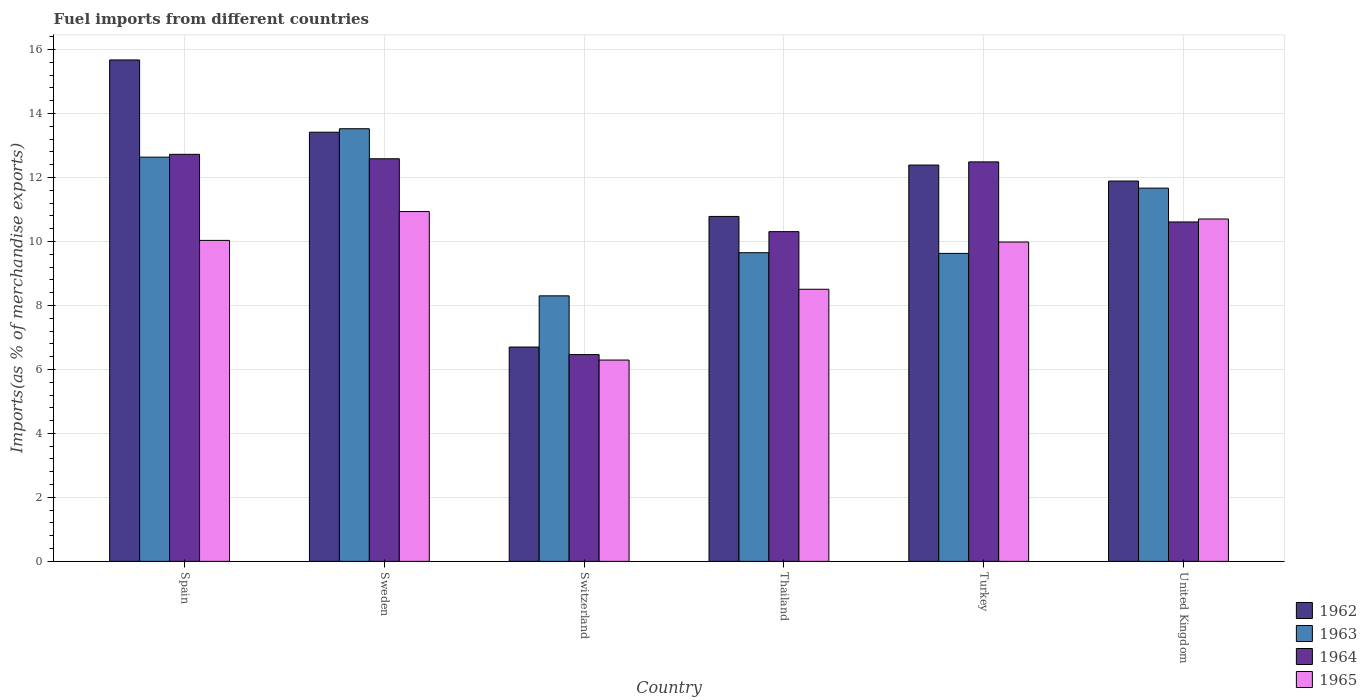How many different coloured bars are there?
Make the answer very short. 4. Are the number of bars on each tick of the X-axis equal?
Your answer should be very brief. Yes. How many bars are there on the 6th tick from the left?
Keep it short and to the point. 4. How many bars are there on the 5th tick from the right?
Keep it short and to the point. 4. What is the label of the 3rd group of bars from the left?
Keep it short and to the point. Switzerland. In how many cases, is the number of bars for a given country not equal to the number of legend labels?
Keep it short and to the point. 0. What is the percentage of imports to different countries in 1962 in Switzerland?
Your answer should be compact. 6.7. Across all countries, what is the maximum percentage of imports to different countries in 1965?
Offer a terse response. 10.93. Across all countries, what is the minimum percentage of imports to different countries in 1962?
Provide a short and direct response. 6.7. In which country was the percentage of imports to different countries in 1964 maximum?
Provide a short and direct response. Spain. In which country was the percentage of imports to different countries in 1962 minimum?
Provide a succinct answer. Switzerland. What is the total percentage of imports to different countries in 1965 in the graph?
Give a very brief answer. 56.45. What is the difference between the percentage of imports to different countries in 1962 in Sweden and that in United Kingdom?
Provide a succinct answer. 1.53. What is the difference between the percentage of imports to different countries in 1962 in Thailand and the percentage of imports to different countries in 1963 in Switzerland?
Your answer should be compact. 2.48. What is the average percentage of imports to different countries in 1962 per country?
Your answer should be very brief. 11.81. What is the difference between the percentage of imports to different countries of/in 1963 and percentage of imports to different countries of/in 1964 in United Kingdom?
Provide a short and direct response. 1.06. What is the ratio of the percentage of imports to different countries in 1963 in Spain to that in United Kingdom?
Ensure brevity in your answer.  1.08. Is the difference between the percentage of imports to different countries in 1963 in Spain and Turkey greater than the difference between the percentage of imports to different countries in 1964 in Spain and Turkey?
Ensure brevity in your answer.  Yes. What is the difference between the highest and the second highest percentage of imports to different countries in 1962?
Make the answer very short. -1.03. What is the difference between the highest and the lowest percentage of imports to different countries in 1963?
Make the answer very short. 5.22. What does the 1st bar from the left in United Kingdom represents?
Provide a short and direct response. 1962. What does the 1st bar from the right in Sweden represents?
Your answer should be compact. 1965. What is the difference between two consecutive major ticks on the Y-axis?
Your answer should be compact. 2. Does the graph contain any zero values?
Your response must be concise. No. Does the graph contain grids?
Your answer should be very brief. Yes. Where does the legend appear in the graph?
Your answer should be compact. Bottom right. How are the legend labels stacked?
Ensure brevity in your answer.  Vertical. What is the title of the graph?
Offer a terse response. Fuel imports from different countries. What is the label or title of the X-axis?
Your response must be concise. Country. What is the label or title of the Y-axis?
Give a very brief answer. Imports(as % of merchandise exports). What is the Imports(as % of merchandise exports) in 1962 in Spain?
Your response must be concise. 15.67. What is the Imports(as % of merchandise exports) in 1963 in Spain?
Make the answer very short. 12.64. What is the Imports(as % of merchandise exports) in 1964 in Spain?
Make the answer very short. 12.72. What is the Imports(as % of merchandise exports) in 1965 in Spain?
Provide a succinct answer. 10.03. What is the Imports(as % of merchandise exports) of 1962 in Sweden?
Provide a succinct answer. 13.42. What is the Imports(as % of merchandise exports) in 1963 in Sweden?
Ensure brevity in your answer.  13.52. What is the Imports(as % of merchandise exports) in 1964 in Sweden?
Offer a terse response. 12.58. What is the Imports(as % of merchandise exports) in 1965 in Sweden?
Provide a short and direct response. 10.93. What is the Imports(as % of merchandise exports) of 1962 in Switzerland?
Keep it short and to the point. 6.7. What is the Imports(as % of merchandise exports) of 1963 in Switzerland?
Make the answer very short. 8.3. What is the Imports(as % of merchandise exports) of 1964 in Switzerland?
Your answer should be compact. 6.46. What is the Imports(as % of merchandise exports) in 1965 in Switzerland?
Keep it short and to the point. 6.29. What is the Imports(as % of merchandise exports) of 1962 in Thailand?
Ensure brevity in your answer.  10.78. What is the Imports(as % of merchandise exports) in 1963 in Thailand?
Your answer should be compact. 9.65. What is the Imports(as % of merchandise exports) in 1964 in Thailand?
Keep it short and to the point. 10.31. What is the Imports(as % of merchandise exports) of 1965 in Thailand?
Provide a succinct answer. 8.51. What is the Imports(as % of merchandise exports) in 1962 in Turkey?
Keep it short and to the point. 12.39. What is the Imports(as % of merchandise exports) in 1963 in Turkey?
Offer a very short reply. 9.63. What is the Imports(as % of merchandise exports) in 1964 in Turkey?
Make the answer very short. 12.49. What is the Imports(as % of merchandise exports) in 1965 in Turkey?
Keep it short and to the point. 9.98. What is the Imports(as % of merchandise exports) of 1962 in United Kingdom?
Ensure brevity in your answer.  11.89. What is the Imports(as % of merchandise exports) in 1963 in United Kingdom?
Your answer should be very brief. 11.67. What is the Imports(as % of merchandise exports) in 1964 in United Kingdom?
Offer a terse response. 10.61. What is the Imports(as % of merchandise exports) in 1965 in United Kingdom?
Make the answer very short. 10.7. Across all countries, what is the maximum Imports(as % of merchandise exports) of 1962?
Give a very brief answer. 15.67. Across all countries, what is the maximum Imports(as % of merchandise exports) of 1963?
Give a very brief answer. 13.52. Across all countries, what is the maximum Imports(as % of merchandise exports) in 1964?
Provide a succinct answer. 12.72. Across all countries, what is the maximum Imports(as % of merchandise exports) of 1965?
Ensure brevity in your answer.  10.93. Across all countries, what is the minimum Imports(as % of merchandise exports) of 1962?
Your answer should be very brief. 6.7. Across all countries, what is the minimum Imports(as % of merchandise exports) of 1963?
Your response must be concise. 8.3. Across all countries, what is the minimum Imports(as % of merchandise exports) in 1964?
Provide a succinct answer. 6.46. Across all countries, what is the minimum Imports(as % of merchandise exports) of 1965?
Your answer should be compact. 6.29. What is the total Imports(as % of merchandise exports) in 1962 in the graph?
Offer a terse response. 70.85. What is the total Imports(as % of merchandise exports) in 1963 in the graph?
Your answer should be very brief. 65.4. What is the total Imports(as % of merchandise exports) in 1964 in the graph?
Your answer should be compact. 65.18. What is the total Imports(as % of merchandise exports) in 1965 in the graph?
Your answer should be very brief. 56.45. What is the difference between the Imports(as % of merchandise exports) of 1962 in Spain and that in Sweden?
Ensure brevity in your answer.  2.26. What is the difference between the Imports(as % of merchandise exports) of 1963 in Spain and that in Sweden?
Your response must be concise. -0.89. What is the difference between the Imports(as % of merchandise exports) of 1964 in Spain and that in Sweden?
Provide a succinct answer. 0.14. What is the difference between the Imports(as % of merchandise exports) in 1965 in Spain and that in Sweden?
Offer a very short reply. -0.9. What is the difference between the Imports(as % of merchandise exports) of 1962 in Spain and that in Switzerland?
Ensure brevity in your answer.  8.97. What is the difference between the Imports(as % of merchandise exports) of 1963 in Spain and that in Switzerland?
Make the answer very short. 4.34. What is the difference between the Imports(as % of merchandise exports) of 1964 in Spain and that in Switzerland?
Your answer should be compact. 6.26. What is the difference between the Imports(as % of merchandise exports) of 1965 in Spain and that in Switzerland?
Your response must be concise. 3.74. What is the difference between the Imports(as % of merchandise exports) in 1962 in Spain and that in Thailand?
Give a very brief answer. 4.89. What is the difference between the Imports(as % of merchandise exports) in 1963 in Spain and that in Thailand?
Your response must be concise. 2.99. What is the difference between the Imports(as % of merchandise exports) of 1964 in Spain and that in Thailand?
Offer a very short reply. 2.42. What is the difference between the Imports(as % of merchandise exports) of 1965 in Spain and that in Thailand?
Keep it short and to the point. 1.53. What is the difference between the Imports(as % of merchandise exports) of 1962 in Spain and that in Turkey?
Ensure brevity in your answer.  3.29. What is the difference between the Imports(as % of merchandise exports) of 1963 in Spain and that in Turkey?
Ensure brevity in your answer.  3.01. What is the difference between the Imports(as % of merchandise exports) of 1964 in Spain and that in Turkey?
Your answer should be compact. 0.24. What is the difference between the Imports(as % of merchandise exports) of 1965 in Spain and that in Turkey?
Your response must be concise. 0.05. What is the difference between the Imports(as % of merchandise exports) in 1962 in Spain and that in United Kingdom?
Give a very brief answer. 3.79. What is the difference between the Imports(as % of merchandise exports) of 1963 in Spain and that in United Kingdom?
Provide a succinct answer. 0.97. What is the difference between the Imports(as % of merchandise exports) in 1964 in Spain and that in United Kingdom?
Your answer should be very brief. 2.11. What is the difference between the Imports(as % of merchandise exports) of 1965 in Spain and that in United Kingdom?
Ensure brevity in your answer.  -0.67. What is the difference between the Imports(as % of merchandise exports) in 1962 in Sweden and that in Switzerland?
Make the answer very short. 6.72. What is the difference between the Imports(as % of merchandise exports) of 1963 in Sweden and that in Switzerland?
Your answer should be very brief. 5.22. What is the difference between the Imports(as % of merchandise exports) in 1964 in Sweden and that in Switzerland?
Provide a short and direct response. 6.12. What is the difference between the Imports(as % of merchandise exports) in 1965 in Sweden and that in Switzerland?
Your answer should be very brief. 4.64. What is the difference between the Imports(as % of merchandise exports) in 1962 in Sweden and that in Thailand?
Ensure brevity in your answer.  2.63. What is the difference between the Imports(as % of merchandise exports) in 1963 in Sweden and that in Thailand?
Make the answer very short. 3.88. What is the difference between the Imports(as % of merchandise exports) of 1964 in Sweden and that in Thailand?
Provide a succinct answer. 2.28. What is the difference between the Imports(as % of merchandise exports) in 1965 in Sweden and that in Thailand?
Give a very brief answer. 2.43. What is the difference between the Imports(as % of merchandise exports) in 1962 in Sweden and that in Turkey?
Your answer should be very brief. 1.03. What is the difference between the Imports(as % of merchandise exports) of 1963 in Sweden and that in Turkey?
Your answer should be compact. 3.9. What is the difference between the Imports(as % of merchandise exports) of 1964 in Sweden and that in Turkey?
Keep it short and to the point. 0.1. What is the difference between the Imports(as % of merchandise exports) in 1965 in Sweden and that in Turkey?
Your response must be concise. 0.95. What is the difference between the Imports(as % of merchandise exports) of 1962 in Sweden and that in United Kingdom?
Your response must be concise. 1.53. What is the difference between the Imports(as % of merchandise exports) of 1963 in Sweden and that in United Kingdom?
Your answer should be very brief. 1.86. What is the difference between the Imports(as % of merchandise exports) in 1964 in Sweden and that in United Kingdom?
Your answer should be compact. 1.97. What is the difference between the Imports(as % of merchandise exports) in 1965 in Sweden and that in United Kingdom?
Offer a terse response. 0.23. What is the difference between the Imports(as % of merchandise exports) of 1962 in Switzerland and that in Thailand?
Provide a short and direct response. -4.08. What is the difference between the Imports(as % of merchandise exports) in 1963 in Switzerland and that in Thailand?
Make the answer very short. -1.35. What is the difference between the Imports(as % of merchandise exports) in 1964 in Switzerland and that in Thailand?
Keep it short and to the point. -3.84. What is the difference between the Imports(as % of merchandise exports) in 1965 in Switzerland and that in Thailand?
Your answer should be compact. -2.21. What is the difference between the Imports(as % of merchandise exports) in 1962 in Switzerland and that in Turkey?
Make the answer very short. -5.69. What is the difference between the Imports(as % of merchandise exports) in 1963 in Switzerland and that in Turkey?
Provide a short and direct response. -1.33. What is the difference between the Imports(as % of merchandise exports) of 1964 in Switzerland and that in Turkey?
Ensure brevity in your answer.  -6.02. What is the difference between the Imports(as % of merchandise exports) in 1965 in Switzerland and that in Turkey?
Your answer should be very brief. -3.69. What is the difference between the Imports(as % of merchandise exports) of 1962 in Switzerland and that in United Kingdom?
Offer a very short reply. -5.19. What is the difference between the Imports(as % of merchandise exports) of 1963 in Switzerland and that in United Kingdom?
Your response must be concise. -3.37. What is the difference between the Imports(as % of merchandise exports) in 1964 in Switzerland and that in United Kingdom?
Make the answer very short. -4.15. What is the difference between the Imports(as % of merchandise exports) of 1965 in Switzerland and that in United Kingdom?
Your answer should be compact. -4.41. What is the difference between the Imports(as % of merchandise exports) of 1962 in Thailand and that in Turkey?
Your answer should be very brief. -1.61. What is the difference between the Imports(as % of merchandise exports) in 1963 in Thailand and that in Turkey?
Provide a succinct answer. 0.02. What is the difference between the Imports(as % of merchandise exports) of 1964 in Thailand and that in Turkey?
Make the answer very short. -2.18. What is the difference between the Imports(as % of merchandise exports) of 1965 in Thailand and that in Turkey?
Provide a succinct answer. -1.48. What is the difference between the Imports(as % of merchandise exports) of 1962 in Thailand and that in United Kingdom?
Keep it short and to the point. -1.11. What is the difference between the Imports(as % of merchandise exports) in 1963 in Thailand and that in United Kingdom?
Provide a short and direct response. -2.02. What is the difference between the Imports(as % of merchandise exports) of 1964 in Thailand and that in United Kingdom?
Give a very brief answer. -0.3. What is the difference between the Imports(as % of merchandise exports) in 1965 in Thailand and that in United Kingdom?
Provide a succinct answer. -2.2. What is the difference between the Imports(as % of merchandise exports) of 1962 in Turkey and that in United Kingdom?
Make the answer very short. 0.5. What is the difference between the Imports(as % of merchandise exports) of 1963 in Turkey and that in United Kingdom?
Keep it short and to the point. -2.04. What is the difference between the Imports(as % of merchandise exports) of 1964 in Turkey and that in United Kingdom?
Provide a short and direct response. 1.88. What is the difference between the Imports(as % of merchandise exports) in 1965 in Turkey and that in United Kingdom?
Make the answer very short. -0.72. What is the difference between the Imports(as % of merchandise exports) of 1962 in Spain and the Imports(as % of merchandise exports) of 1963 in Sweden?
Your answer should be compact. 2.15. What is the difference between the Imports(as % of merchandise exports) in 1962 in Spain and the Imports(as % of merchandise exports) in 1964 in Sweden?
Ensure brevity in your answer.  3.09. What is the difference between the Imports(as % of merchandise exports) in 1962 in Spain and the Imports(as % of merchandise exports) in 1965 in Sweden?
Offer a very short reply. 4.74. What is the difference between the Imports(as % of merchandise exports) of 1963 in Spain and the Imports(as % of merchandise exports) of 1964 in Sweden?
Give a very brief answer. 0.05. What is the difference between the Imports(as % of merchandise exports) of 1963 in Spain and the Imports(as % of merchandise exports) of 1965 in Sweden?
Your answer should be compact. 1.7. What is the difference between the Imports(as % of merchandise exports) in 1964 in Spain and the Imports(as % of merchandise exports) in 1965 in Sweden?
Your response must be concise. 1.79. What is the difference between the Imports(as % of merchandise exports) in 1962 in Spain and the Imports(as % of merchandise exports) in 1963 in Switzerland?
Make the answer very short. 7.37. What is the difference between the Imports(as % of merchandise exports) in 1962 in Spain and the Imports(as % of merchandise exports) in 1964 in Switzerland?
Offer a very short reply. 9.21. What is the difference between the Imports(as % of merchandise exports) of 1962 in Spain and the Imports(as % of merchandise exports) of 1965 in Switzerland?
Make the answer very short. 9.38. What is the difference between the Imports(as % of merchandise exports) of 1963 in Spain and the Imports(as % of merchandise exports) of 1964 in Switzerland?
Provide a succinct answer. 6.17. What is the difference between the Imports(as % of merchandise exports) of 1963 in Spain and the Imports(as % of merchandise exports) of 1965 in Switzerland?
Your answer should be compact. 6.34. What is the difference between the Imports(as % of merchandise exports) in 1964 in Spain and the Imports(as % of merchandise exports) in 1965 in Switzerland?
Give a very brief answer. 6.43. What is the difference between the Imports(as % of merchandise exports) in 1962 in Spain and the Imports(as % of merchandise exports) in 1963 in Thailand?
Provide a succinct answer. 6.03. What is the difference between the Imports(as % of merchandise exports) in 1962 in Spain and the Imports(as % of merchandise exports) in 1964 in Thailand?
Provide a succinct answer. 5.37. What is the difference between the Imports(as % of merchandise exports) of 1962 in Spain and the Imports(as % of merchandise exports) of 1965 in Thailand?
Offer a very short reply. 7.17. What is the difference between the Imports(as % of merchandise exports) of 1963 in Spain and the Imports(as % of merchandise exports) of 1964 in Thailand?
Offer a terse response. 2.33. What is the difference between the Imports(as % of merchandise exports) of 1963 in Spain and the Imports(as % of merchandise exports) of 1965 in Thailand?
Your response must be concise. 4.13. What is the difference between the Imports(as % of merchandise exports) of 1964 in Spain and the Imports(as % of merchandise exports) of 1965 in Thailand?
Offer a terse response. 4.22. What is the difference between the Imports(as % of merchandise exports) of 1962 in Spain and the Imports(as % of merchandise exports) of 1963 in Turkey?
Make the answer very short. 6.05. What is the difference between the Imports(as % of merchandise exports) of 1962 in Spain and the Imports(as % of merchandise exports) of 1964 in Turkey?
Your response must be concise. 3.19. What is the difference between the Imports(as % of merchandise exports) of 1962 in Spain and the Imports(as % of merchandise exports) of 1965 in Turkey?
Give a very brief answer. 5.69. What is the difference between the Imports(as % of merchandise exports) of 1963 in Spain and the Imports(as % of merchandise exports) of 1964 in Turkey?
Keep it short and to the point. 0.15. What is the difference between the Imports(as % of merchandise exports) of 1963 in Spain and the Imports(as % of merchandise exports) of 1965 in Turkey?
Your answer should be compact. 2.65. What is the difference between the Imports(as % of merchandise exports) of 1964 in Spain and the Imports(as % of merchandise exports) of 1965 in Turkey?
Keep it short and to the point. 2.74. What is the difference between the Imports(as % of merchandise exports) in 1962 in Spain and the Imports(as % of merchandise exports) in 1963 in United Kingdom?
Provide a short and direct response. 4.01. What is the difference between the Imports(as % of merchandise exports) of 1962 in Spain and the Imports(as % of merchandise exports) of 1964 in United Kingdom?
Give a very brief answer. 5.06. What is the difference between the Imports(as % of merchandise exports) of 1962 in Spain and the Imports(as % of merchandise exports) of 1965 in United Kingdom?
Your answer should be compact. 4.97. What is the difference between the Imports(as % of merchandise exports) of 1963 in Spain and the Imports(as % of merchandise exports) of 1964 in United Kingdom?
Offer a very short reply. 2.03. What is the difference between the Imports(as % of merchandise exports) in 1963 in Spain and the Imports(as % of merchandise exports) in 1965 in United Kingdom?
Provide a succinct answer. 1.93. What is the difference between the Imports(as % of merchandise exports) in 1964 in Spain and the Imports(as % of merchandise exports) in 1965 in United Kingdom?
Provide a succinct answer. 2.02. What is the difference between the Imports(as % of merchandise exports) in 1962 in Sweden and the Imports(as % of merchandise exports) in 1963 in Switzerland?
Provide a succinct answer. 5.12. What is the difference between the Imports(as % of merchandise exports) in 1962 in Sweden and the Imports(as % of merchandise exports) in 1964 in Switzerland?
Offer a very short reply. 6.95. What is the difference between the Imports(as % of merchandise exports) of 1962 in Sweden and the Imports(as % of merchandise exports) of 1965 in Switzerland?
Give a very brief answer. 7.12. What is the difference between the Imports(as % of merchandise exports) of 1963 in Sweden and the Imports(as % of merchandise exports) of 1964 in Switzerland?
Your response must be concise. 7.06. What is the difference between the Imports(as % of merchandise exports) in 1963 in Sweden and the Imports(as % of merchandise exports) in 1965 in Switzerland?
Give a very brief answer. 7.23. What is the difference between the Imports(as % of merchandise exports) of 1964 in Sweden and the Imports(as % of merchandise exports) of 1965 in Switzerland?
Ensure brevity in your answer.  6.29. What is the difference between the Imports(as % of merchandise exports) in 1962 in Sweden and the Imports(as % of merchandise exports) in 1963 in Thailand?
Your response must be concise. 3.77. What is the difference between the Imports(as % of merchandise exports) in 1962 in Sweden and the Imports(as % of merchandise exports) in 1964 in Thailand?
Your response must be concise. 3.11. What is the difference between the Imports(as % of merchandise exports) of 1962 in Sweden and the Imports(as % of merchandise exports) of 1965 in Thailand?
Your response must be concise. 4.91. What is the difference between the Imports(as % of merchandise exports) in 1963 in Sweden and the Imports(as % of merchandise exports) in 1964 in Thailand?
Provide a short and direct response. 3.22. What is the difference between the Imports(as % of merchandise exports) of 1963 in Sweden and the Imports(as % of merchandise exports) of 1965 in Thailand?
Offer a terse response. 5.02. What is the difference between the Imports(as % of merchandise exports) in 1964 in Sweden and the Imports(as % of merchandise exports) in 1965 in Thailand?
Your answer should be very brief. 4.08. What is the difference between the Imports(as % of merchandise exports) in 1962 in Sweden and the Imports(as % of merchandise exports) in 1963 in Turkey?
Your answer should be very brief. 3.79. What is the difference between the Imports(as % of merchandise exports) of 1962 in Sweden and the Imports(as % of merchandise exports) of 1964 in Turkey?
Ensure brevity in your answer.  0.93. What is the difference between the Imports(as % of merchandise exports) of 1962 in Sweden and the Imports(as % of merchandise exports) of 1965 in Turkey?
Offer a very short reply. 3.43. What is the difference between the Imports(as % of merchandise exports) in 1963 in Sweden and the Imports(as % of merchandise exports) in 1964 in Turkey?
Your response must be concise. 1.04. What is the difference between the Imports(as % of merchandise exports) of 1963 in Sweden and the Imports(as % of merchandise exports) of 1965 in Turkey?
Offer a very short reply. 3.54. What is the difference between the Imports(as % of merchandise exports) in 1964 in Sweden and the Imports(as % of merchandise exports) in 1965 in Turkey?
Ensure brevity in your answer.  2.6. What is the difference between the Imports(as % of merchandise exports) of 1962 in Sweden and the Imports(as % of merchandise exports) of 1963 in United Kingdom?
Ensure brevity in your answer.  1.75. What is the difference between the Imports(as % of merchandise exports) in 1962 in Sweden and the Imports(as % of merchandise exports) in 1964 in United Kingdom?
Provide a succinct answer. 2.81. What is the difference between the Imports(as % of merchandise exports) in 1962 in Sweden and the Imports(as % of merchandise exports) in 1965 in United Kingdom?
Provide a succinct answer. 2.71. What is the difference between the Imports(as % of merchandise exports) in 1963 in Sweden and the Imports(as % of merchandise exports) in 1964 in United Kingdom?
Offer a very short reply. 2.91. What is the difference between the Imports(as % of merchandise exports) of 1963 in Sweden and the Imports(as % of merchandise exports) of 1965 in United Kingdom?
Keep it short and to the point. 2.82. What is the difference between the Imports(as % of merchandise exports) of 1964 in Sweden and the Imports(as % of merchandise exports) of 1965 in United Kingdom?
Offer a very short reply. 1.88. What is the difference between the Imports(as % of merchandise exports) of 1962 in Switzerland and the Imports(as % of merchandise exports) of 1963 in Thailand?
Keep it short and to the point. -2.95. What is the difference between the Imports(as % of merchandise exports) in 1962 in Switzerland and the Imports(as % of merchandise exports) in 1964 in Thailand?
Offer a terse response. -3.61. What is the difference between the Imports(as % of merchandise exports) of 1962 in Switzerland and the Imports(as % of merchandise exports) of 1965 in Thailand?
Your answer should be very brief. -1.81. What is the difference between the Imports(as % of merchandise exports) of 1963 in Switzerland and the Imports(as % of merchandise exports) of 1964 in Thailand?
Keep it short and to the point. -2.01. What is the difference between the Imports(as % of merchandise exports) in 1963 in Switzerland and the Imports(as % of merchandise exports) in 1965 in Thailand?
Give a very brief answer. -0.21. What is the difference between the Imports(as % of merchandise exports) of 1964 in Switzerland and the Imports(as % of merchandise exports) of 1965 in Thailand?
Give a very brief answer. -2.04. What is the difference between the Imports(as % of merchandise exports) of 1962 in Switzerland and the Imports(as % of merchandise exports) of 1963 in Turkey?
Ensure brevity in your answer.  -2.93. What is the difference between the Imports(as % of merchandise exports) in 1962 in Switzerland and the Imports(as % of merchandise exports) in 1964 in Turkey?
Ensure brevity in your answer.  -5.79. What is the difference between the Imports(as % of merchandise exports) of 1962 in Switzerland and the Imports(as % of merchandise exports) of 1965 in Turkey?
Offer a terse response. -3.28. What is the difference between the Imports(as % of merchandise exports) in 1963 in Switzerland and the Imports(as % of merchandise exports) in 1964 in Turkey?
Provide a short and direct response. -4.19. What is the difference between the Imports(as % of merchandise exports) of 1963 in Switzerland and the Imports(as % of merchandise exports) of 1965 in Turkey?
Keep it short and to the point. -1.68. What is the difference between the Imports(as % of merchandise exports) in 1964 in Switzerland and the Imports(as % of merchandise exports) in 1965 in Turkey?
Your answer should be very brief. -3.52. What is the difference between the Imports(as % of merchandise exports) of 1962 in Switzerland and the Imports(as % of merchandise exports) of 1963 in United Kingdom?
Offer a very short reply. -4.97. What is the difference between the Imports(as % of merchandise exports) of 1962 in Switzerland and the Imports(as % of merchandise exports) of 1964 in United Kingdom?
Your answer should be very brief. -3.91. What is the difference between the Imports(as % of merchandise exports) of 1962 in Switzerland and the Imports(as % of merchandise exports) of 1965 in United Kingdom?
Your answer should be very brief. -4. What is the difference between the Imports(as % of merchandise exports) of 1963 in Switzerland and the Imports(as % of merchandise exports) of 1964 in United Kingdom?
Make the answer very short. -2.31. What is the difference between the Imports(as % of merchandise exports) of 1963 in Switzerland and the Imports(as % of merchandise exports) of 1965 in United Kingdom?
Make the answer very short. -2.4. What is the difference between the Imports(as % of merchandise exports) of 1964 in Switzerland and the Imports(as % of merchandise exports) of 1965 in United Kingdom?
Make the answer very short. -4.24. What is the difference between the Imports(as % of merchandise exports) of 1962 in Thailand and the Imports(as % of merchandise exports) of 1963 in Turkey?
Your answer should be very brief. 1.16. What is the difference between the Imports(as % of merchandise exports) of 1962 in Thailand and the Imports(as % of merchandise exports) of 1964 in Turkey?
Provide a succinct answer. -1.71. What is the difference between the Imports(as % of merchandise exports) of 1962 in Thailand and the Imports(as % of merchandise exports) of 1965 in Turkey?
Your answer should be compact. 0.8. What is the difference between the Imports(as % of merchandise exports) of 1963 in Thailand and the Imports(as % of merchandise exports) of 1964 in Turkey?
Make the answer very short. -2.84. What is the difference between the Imports(as % of merchandise exports) of 1963 in Thailand and the Imports(as % of merchandise exports) of 1965 in Turkey?
Give a very brief answer. -0.33. What is the difference between the Imports(as % of merchandise exports) of 1964 in Thailand and the Imports(as % of merchandise exports) of 1965 in Turkey?
Your response must be concise. 0.32. What is the difference between the Imports(as % of merchandise exports) in 1962 in Thailand and the Imports(as % of merchandise exports) in 1963 in United Kingdom?
Your response must be concise. -0.89. What is the difference between the Imports(as % of merchandise exports) in 1962 in Thailand and the Imports(as % of merchandise exports) in 1964 in United Kingdom?
Your answer should be compact. 0.17. What is the difference between the Imports(as % of merchandise exports) of 1962 in Thailand and the Imports(as % of merchandise exports) of 1965 in United Kingdom?
Offer a terse response. 0.08. What is the difference between the Imports(as % of merchandise exports) in 1963 in Thailand and the Imports(as % of merchandise exports) in 1964 in United Kingdom?
Your response must be concise. -0.96. What is the difference between the Imports(as % of merchandise exports) of 1963 in Thailand and the Imports(as % of merchandise exports) of 1965 in United Kingdom?
Offer a very short reply. -1.05. What is the difference between the Imports(as % of merchandise exports) in 1964 in Thailand and the Imports(as % of merchandise exports) in 1965 in United Kingdom?
Give a very brief answer. -0.4. What is the difference between the Imports(as % of merchandise exports) in 1962 in Turkey and the Imports(as % of merchandise exports) in 1963 in United Kingdom?
Your response must be concise. 0.72. What is the difference between the Imports(as % of merchandise exports) in 1962 in Turkey and the Imports(as % of merchandise exports) in 1964 in United Kingdom?
Provide a succinct answer. 1.78. What is the difference between the Imports(as % of merchandise exports) in 1962 in Turkey and the Imports(as % of merchandise exports) in 1965 in United Kingdom?
Your response must be concise. 1.69. What is the difference between the Imports(as % of merchandise exports) in 1963 in Turkey and the Imports(as % of merchandise exports) in 1964 in United Kingdom?
Keep it short and to the point. -0.98. What is the difference between the Imports(as % of merchandise exports) of 1963 in Turkey and the Imports(as % of merchandise exports) of 1965 in United Kingdom?
Your answer should be very brief. -1.08. What is the difference between the Imports(as % of merchandise exports) of 1964 in Turkey and the Imports(as % of merchandise exports) of 1965 in United Kingdom?
Ensure brevity in your answer.  1.78. What is the average Imports(as % of merchandise exports) in 1962 per country?
Provide a succinct answer. 11.81. What is the average Imports(as % of merchandise exports) in 1963 per country?
Give a very brief answer. 10.9. What is the average Imports(as % of merchandise exports) in 1964 per country?
Ensure brevity in your answer.  10.86. What is the average Imports(as % of merchandise exports) of 1965 per country?
Offer a very short reply. 9.41. What is the difference between the Imports(as % of merchandise exports) in 1962 and Imports(as % of merchandise exports) in 1963 in Spain?
Ensure brevity in your answer.  3.04. What is the difference between the Imports(as % of merchandise exports) in 1962 and Imports(as % of merchandise exports) in 1964 in Spain?
Provide a short and direct response. 2.95. What is the difference between the Imports(as % of merchandise exports) in 1962 and Imports(as % of merchandise exports) in 1965 in Spain?
Provide a short and direct response. 5.64. What is the difference between the Imports(as % of merchandise exports) of 1963 and Imports(as % of merchandise exports) of 1964 in Spain?
Keep it short and to the point. -0.09. What is the difference between the Imports(as % of merchandise exports) in 1963 and Imports(as % of merchandise exports) in 1965 in Spain?
Make the answer very short. 2.6. What is the difference between the Imports(as % of merchandise exports) of 1964 and Imports(as % of merchandise exports) of 1965 in Spain?
Give a very brief answer. 2.69. What is the difference between the Imports(as % of merchandise exports) of 1962 and Imports(as % of merchandise exports) of 1963 in Sweden?
Your answer should be very brief. -0.11. What is the difference between the Imports(as % of merchandise exports) of 1962 and Imports(as % of merchandise exports) of 1964 in Sweden?
Make the answer very short. 0.83. What is the difference between the Imports(as % of merchandise exports) in 1962 and Imports(as % of merchandise exports) in 1965 in Sweden?
Offer a terse response. 2.48. What is the difference between the Imports(as % of merchandise exports) in 1963 and Imports(as % of merchandise exports) in 1964 in Sweden?
Offer a very short reply. 0.94. What is the difference between the Imports(as % of merchandise exports) of 1963 and Imports(as % of merchandise exports) of 1965 in Sweden?
Keep it short and to the point. 2.59. What is the difference between the Imports(as % of merchandise exports) of 1964 and Imports(as % of merchandise exports) of 1965 in Sweden?
Keep it short and to the point. 1.65. What is the difference between the Imports(as % of merchandise exports) of 1962 and Imports(as % of merchandise exports) of 1963 in Switzerland?
Ensure brevity in your answer.  -1.6. What is the difference between the Imports(as % of merchandise exports) of 1962 and Imports(as % of merchandise exports) of 1964 in Switzerland?
Provide a succinct answer. 0.24. What is the difference between the Imports(as % of merchandise exports) in 1962 and Imports(as % of merchandise exports) in 1965 in Switzerland?
Provide a short and direct response. 0.41. What is the difference between the Imports(as % of merchandise exports) in 1963 and Imports(as % of merchandise exports) in 1964 in Switzerland?
Keep it short and to the point. 1.84. What is the difference between the Imports(as % of merchandise exports) of 1963 and Imports(as % of merchandise exports) of 1965 in Switzerland?
Provide a succinct answer. 2.01. What is the difference between the Imports(as % of merchandise exports) of 1964 and Imports(as % of merchandise exports) of 1965 in Switzerland?
Give a very brief answer. 0.17. What is the difference between the Imports(as % of merchandise exports) of 1962 and Imports(as % of merchandise exports) of 1963 in Thailand?
Make the answer very short. 1.13. What is the difference between the Imports(as % of merchandise exports) of 1962 and Imports(as % of merchandise exports) of 1964 in Thailand?
Your answer should be very brief. 0.48. What is the difference between the Imports(as % of merchandise exports) in 1962 and Imports(as % of merchandise exports) in 1965 in Thailand?
Your response must be concise. 2.28. What is the difference between the Imports(as % of merchandise exports) of 1963 and Imports(as % of merchandise exports) of 1964 in Thailand?
Offer a very short reply. -0.66. What is the difference between the Imports(as % of merchandise exports) of 1963 and Imports(as % of merchandise exports) of 1965 in Thailand?
Offer a terse response. 1.14. What is the difference between the Imports(as % of merchandise exports) of 1964 and Imports(as % of merchandise exports) of 1965 in Thailand?
Your answer should be very brief. 1.8. What is the difference between the Imports(as % of merchandise exports) in 1962 and Imports(as % of merchandise exports) in 1963 in Turkey?
Offer a terse response. 2.76. What is the difference between the Imports(as % of merchandise exports) of 1962 and Imports(as % of merchandise exports) of 1964 in Turkey?
Give a very brief answer. -0.1. What is the difference between the Imports(as % of merchandise exports) of 1962 and Imports(as % of merchandise exports) of 1965 in Turkey?
Your answer should be very brief. 2.41. What is the difference between the Imports(as % of merchandise exports) in 1963 and Imports(as % of merchandise exports) in 1964 in Turkey?
Make the answer very short. -2.86. What is the difference between the Imports(as % of merchandise exports) of 1963 and Imports(as % of merchandise exports) of 1965 in Turkey?
Your response must be concise. -0.36. What is the difference between the Imports(as % of merchandise exports) in 1964 and Imports(as % of merchandise exports) in 1965 in Turkey?
Offer a very short reply. 2.51. What is the difference between the Imports(as % of merchandise exports) of 1962 and Imports(as % of merchandise exports) of 1963 in United Kingdom?
Offer a very short reply. 0.22. What is the difference between the Imports(as % of merchandise exports) in 1962 and Imports(as % of merchandise exports) in 1964 in United Kingdom?
Your answer should be very brief. 1.28. What is the difference between the Imports(as % of merchandise exports) in 1962 and Imports(as % of merchandise exports) in 1965 in United Kingdom?
Provide a short and direct response. 1.19. What is the difference between the Imports(as % of merchandise exports) of 1963 and Imports(as % of merchandise exports) of 1964 in United Kingdom?
Your answer should be very brief. 1.06. What is the difference between the Imports(as % of merchandise exports) in 1964 and Imports(as % of merchandise exports) in 1965 in United Kingdom?
Your response must be concise. -0.09. What is the ratio of the Imports(as % of merchandise exports) in 1962 in Spain to that in Sweden?
Ensure brevity in your answer.  1.17. What is the ratio of the Imports(as % of merchandise exports) in 1963 in Spain to that in Sweden?
Keep it short and to the point. 0.93. What is the ratio of the Imports(as % of merchandise exports) in 1965 in Spain to that in Sweden?
Your answer should be very brief. 0.92. What is the ratio of the Imports(as % of merchandise exports) in 1962 in Spain to that in Switzerland?
Your response must be concise. 2.34. What is the ratio of the Imports(as % of merchandise exports) of 1963 in Spain to that in Switzerland?
Ensure brevity in your answer.  1.52. What is the ratio of the Imports(as % of merchandise exports) of 1964 in Spain to that in Switzerland?
Provide a short and direct response. 1.97. What is the ratio of the Imports(as % of merchandise exports) in 1965 in Spain to that in Switzerland?
Offer a terse response. 1.59. What is the ratio of the Imports(as % of merchandise exports) of 1962 in Spain to that in Thailand?
Offer a very short reply. 1.45. What is the ratio of the Imports(as % of merchandise exports) of 1963 in Spain to that in Thailand?
Offer a very short reply. 1.31. What is the ratio of the Imports(as % of merchandise exports) of 1964 in Spain to that in Thailand?
Keep it short and to the point. 1.23. What is the ratio of the Imports(as % of merchandise exports) in 1965 in Spain to that in Thailand?
Provide a short and direct response. 1.18. What is the ratio of the Imports(as % of merchandise exports) in 1962 in Spain to that in Turkey?
Your answer should be compact. 1.27. What is the ratio of the Imports(as % of merchandise exports) in 1963 in Spain to that in Turkey?
Offer a very short reply. 1.31. What is the ratio of the Imports(as % of merchandise exports) in 1964 in Spain to that in Turkey?
Your answer should be compact. 1.02. What is the ratio of the Imports(as % of merchandise exports) in 1965 in Spain to that in Turkey?
Keep it short and to the point. 1.01. What is the ratio of the Imports(as % of merchandise exports) in 1962 in Spain to that in United Kingdom?
Provide a succinct answer. 1.32. What is the ratio of the Imports(as % of merchandise exports) in 1963 in Spain to that in United Kingdom?
Offer a very short reply. 1.08. What is the ratio of the Imports(as % of merchandise exports) in 1964 in Spain to that in United Kingdom?
Your answer should be compact. 1.2. What is the ratio of the Imports(as % of merchandise exports) in 1965 in Spain to that in United Kingdom?
Give a very brief answer. 0.94. What is the ratio of the Imports(as % of merchandise exports) of 1962 in Sweden to that in Switzerland?
Give a very brief answer. 2. What is the ratio of the Imports(as % of merchandise exports) of 1963 in Sweden to that in Switzerland?
Keep it short and to the point. 1.63. What is the ratio of the Imports(as % of merchandise exports) of 1964 in Sweden to that in Switzerland?
Provide a succinct answer. 1.95. What is the ratio of the Imports(as % of merchandise exports) of 1965 in Sweden to that in Switzerland?
Your answer should be very brief. 1.74. What is the ratio of the Imports(as % of merchandise exports) in 1962 in Sweden to that in Thailand?
Offer a very short reply. 1.24. What is the ratio of the Imports(as % of merchandise exports) of 1963 in Sweden to that in Thailand?
Your response must be concise. 1.4. What is the ratio of the Imports(as % of merchandise exports) in 1964 in Sweden to that in Thailand?
Provide a short and direct response. 1.22. What is the ratio of the Imports(as % of merchandise exports) in 1965 in Sweden to that in Thailand?
Your answer should be compact. 1.29. What is the ratio of the Imports(as % of merchandise exports) of 1962 in Sweden to that in Turkey?
Make the answer very short. 1.08. What is the ratio of the Imports(as % of merchandise exports) of 1963 in Sweden to that in Turkey?
Make the answer very short. 1.4. What is the ratio of the Imports(as % of merchandise exports) in 1965 in Sweden to that in Turkey?
Offer a terse response. 1.1. What is the ratio of the Imports(as % of merchandise exports) in 1962 in Sweden to that in United Kingdom?
Give a very brief answer. 1.13. What is the ratio of the Imports(as % of merchandise exports) in 1963 in Sweden to that in United Kingdom?
Your response must be concise. 1.16. What is the ratio of the Imports(as % of merchandise exports) in 1964 in Sweden to that in United Kingdom?
Your answer should be very brief. 1.19. What is the ratio of the Imports(as % of merchandise exports) in 1965 in Sweden to that in United Kingdom?
Offer a very short reply. 1.02. What is the ratio of the Imports(as % of merchandise exports) in 1962 in Switzerland to that in Thailand?
Your answer should be compact. 0.62. What is the ratio of the Imports(as % of merchandise exports) of 1963 in Switzerland to that in Thailand?
Offer a terse response. 0.86. What is the ratio of the Imports(as % of merchandise exports) of 1964 in Switzerland to that in Thailand?
Give a very brief answer. 0.63. What is the ratio of the Imports(as % of merchandise exports) in 1965 in Switzerland to that in Thailand?
Offer a very short reply. 0.74. What is the ratio of the Imports(as % of merchandise exports) in 1962 in Switzerland to that in Turkey?
Your answer should be very brief. 0.54. What is the ratio of the Imports(as % of merchandise exports) of 1963 in Switzerland to that in Turkey?
Provide a short and direct response. 0.86. What is the ratio of the Imports(as % of merchandise exports) of 1964 in Switzerland to that in Turkey?
Your answer should be very brief. 0.52. What is the ratio of the Imports(as % of merchandise exports) in 1965 in Switzerland to that in Turkey?
Keep it short and to the point. 0.63. What is the ratio of the Imports(as % of merchandise exports) in 1962 in Switzerland to that in United Kingdom?
Give a very brief answer. 0.56. What is the ratio of the Imports(as % of merchandise exports) of 1963 in Switzerland to that in United Kingdom?
Provide a short and direct response. 0.71. What is the ratio of the Imports(as % of merchandise exports) in 1964 in Switzerland to that in United Kingdom?
Provide a succinct answer. 0.61. What is the ratio of the Imports(as % of merchandise exports) of 1965 in Switzerland to that in United Kingdom?
Offer a terse response. 0.59. What is the ratio of the Imports(as % of merchandise exports) in 1962 in Thailand to that in Turkey?
Your response must be concise. 0.87. What is the ratio of the Imports(as % of merchandise exports) of 1963 in Thailand to that in Turkey?
Your answer should be compact. 1. What is the ratio of the Imports(as % of merchandise exports) of 1964 in Thailand to that in Turkey?
Keep it short and to the point. 0.83. What is the ratio of the Imports(as % of merchandise exports) in 1965 in Thailand to that in Turkey?
Your answer should be compact. 0.85. What is the ratio of the Imports(as % of merchandise exports) in 1962 in Thailand to that in United Kingdom?
Make the answer very short. 0.91. What is the ratio of the Imports(as % of merchandise exports) of 1963 in Thailand to that in United Kingdom?
Offer a terse response. 0.83. What is the ratio of the Imports(as % of merchandise exports) of 1964 in Thailand to that in United Kingdom?
Keep it short and to the point. 0.97. What is the ratio of the Imports(as % of merchandise exports) in 1965 in Thailand to that in United Kingdom?
Your answer should be very brief. 0.79. What is the ratio of the Imports(as % of merchandise exports) in 1962 in Turkey to that in United Kingdom?
Offer a very short reply. 1.04. What is the ratio of the Imports(as % of merchandise exports) of 1963 in Turkey to that in United Kingdom?
Give a very brief answer. 0.83. What is the ratio of the Imports(as % of merchandise exports) of 1964 in Turkey to that in United Kingdom?
Your answer should be compact. 1.18. What is the ratio of the Imports(as % of merchandise exports) of 1965 in Turkey to that in United Kingdom?
Make the answer very short. 0.93. What is the difference between the highest and the second highest Imports(as % of merchandise exports) in 1962?
Offer a very short reply. 2.26. What is the difference between the highest and the second highest Imports(as % of merchandise exports) in 1963?
Your answer should be very brief. 0.89. What is the difference between the highest and the second highest Imports(as % of merchandise exports) in 1964?
Offer a very short reply. 0.14. What is the difference between the highest and the second highest Imports(as % of merchandise exports) of 1965?
Keep it short and to the point. 0.23. What is the difference between the highest and the lowest Imports(as % of merchandise exports) in 1962?
Make the answer very short. 8.97. What is the difference between the highest and the lowest Imports(as % of merchandise exports) in 1963?
Ensure brevity in your answer.  5.22. What is the difference between the highest and the lowest Imports(as % of merchandise exports) of 1964?
Your response must be concise. 6.26. What is the difference between the highest and the lowest Imports(as % of merchandise exports) of 1965?
Your response must be concise. 4.64. 